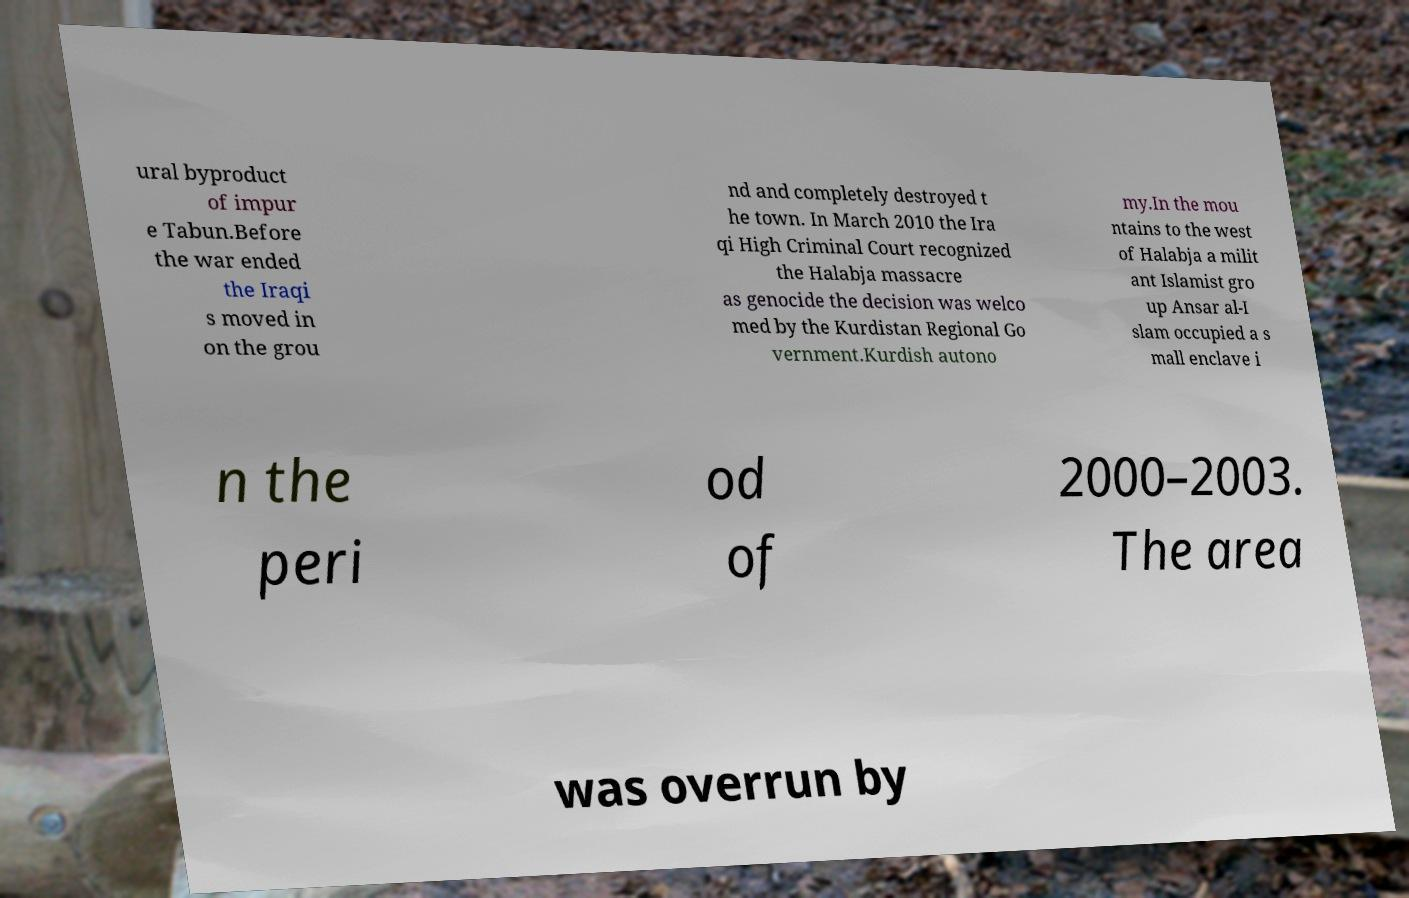What messages or text are displayed in this image? I need them in a readable, typed format. ural byproduct of impur e Tabun.Before the war ended the Iraqi s moved in on the grou nd and completely destroyed t he town. In March 2010 the Ira qi High Criminal Court recognized the Halabja massacre as genocide the decision was welco med by the Kurdistan Regional Go vernment.Kurdish autono my.In the mou ntains to the west of Halabja a milit ant Islamist gro up Ansar al-I slam occupied a s mall enclave i n the peri od of 2000–2003. The area was overrun by 